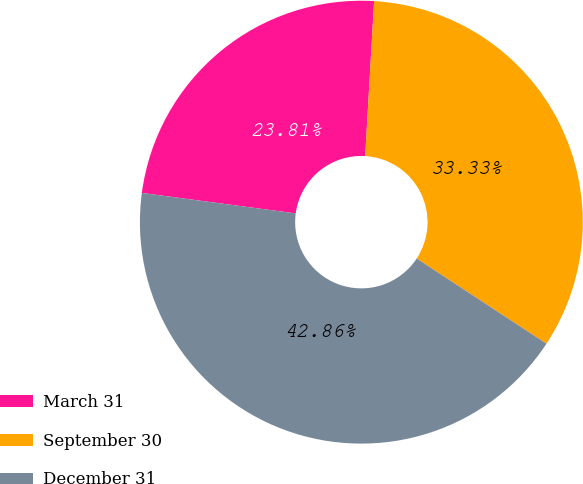Convert chart. <chart><loc_0><loc_0><loc_500><loc_500><pie_chart><fcel>March 31<fcel>September 30<fcel>December 31<nl><fcel>23.81%<fcel>33.33%<fcel>42.86%<nl></chart> 